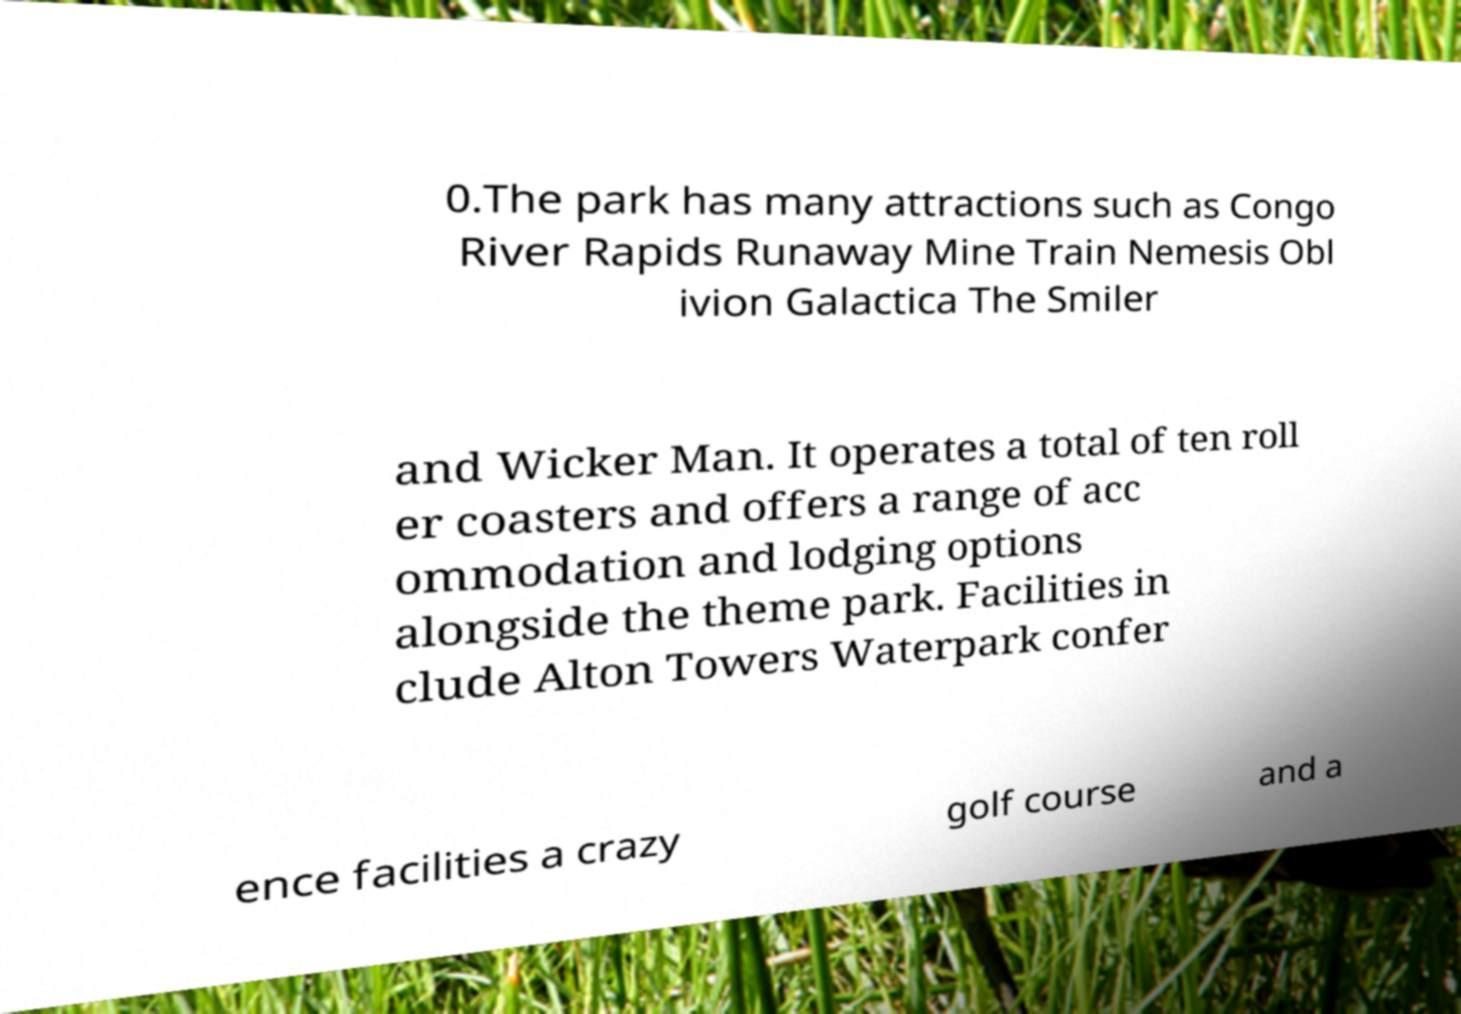Please read and relay the text visible in this image. What does it say? 0.The park has many attractions such as Congo River Rapids Runaway Mine Train Nemesis Obl ivion Galactica The Smiler and Wicker Man. It operates a total of ten roll er coasters and offers a range of acc ommodation and lodging options alongside the theme park. Facilities in clude Alton Towers Waterpark confer ence facilities a crazy golf course and a 